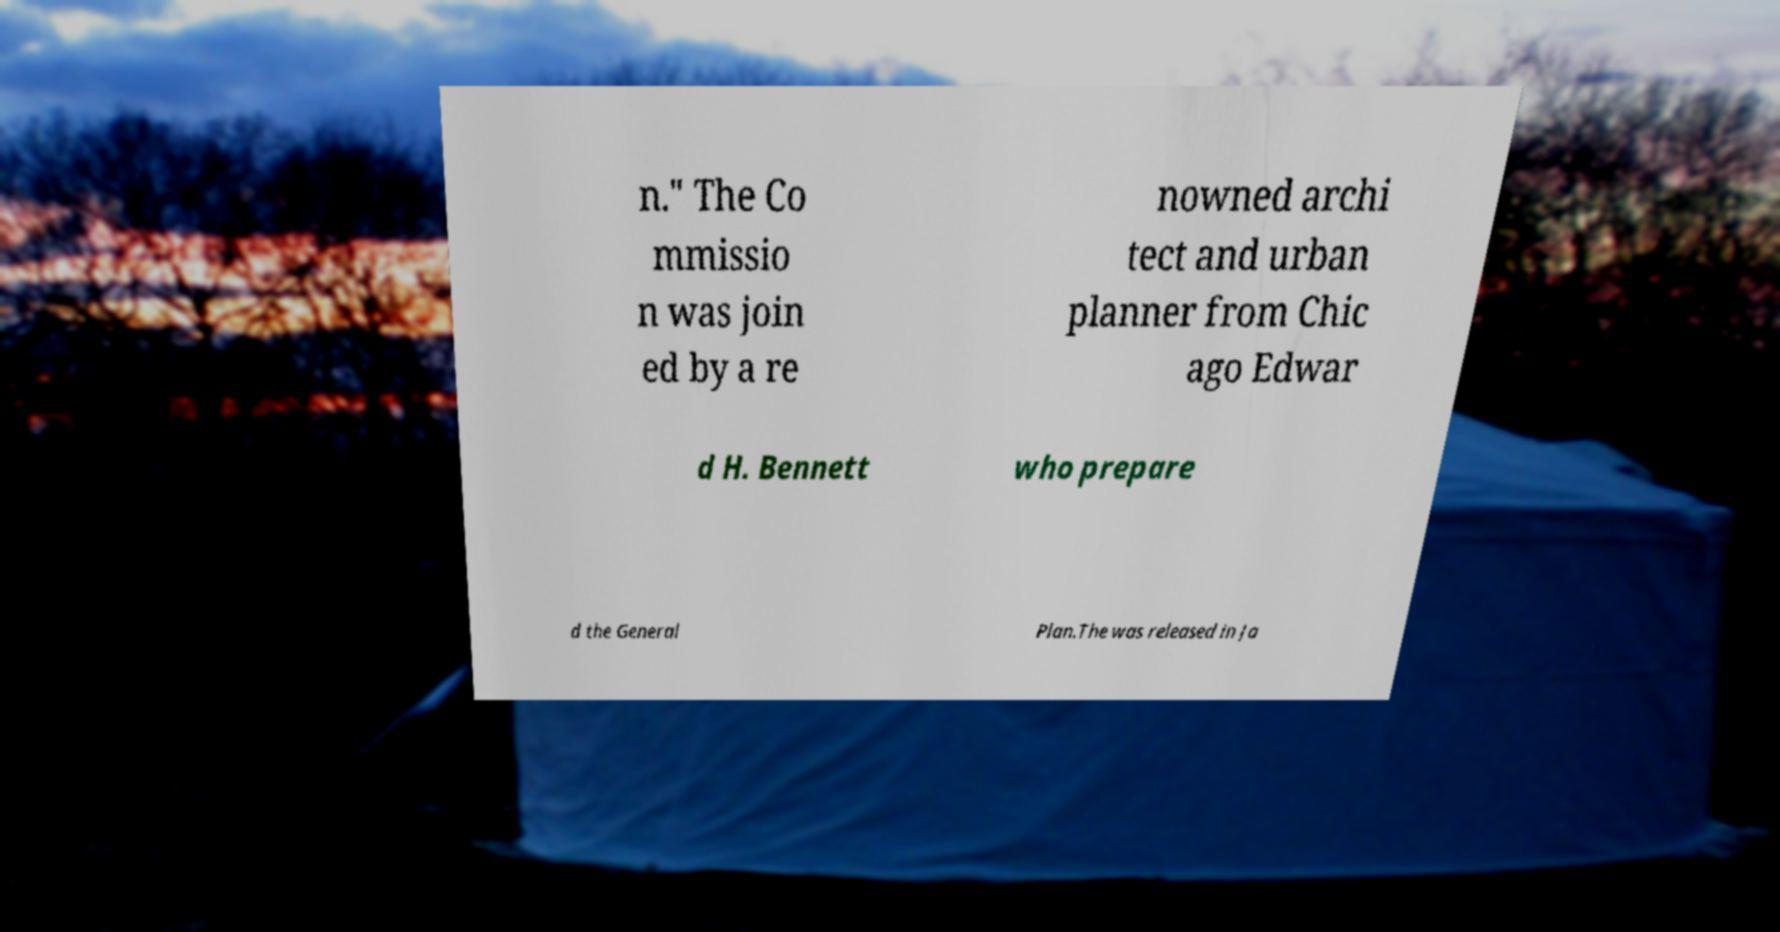Can you read and provide the text displayed in the image?This photo seems to have some interesting text. Can you extract and type it out for me? n." The Co mmissio n was join ed by a re nowned archi tect and urban planner from Chic ago Edwar d H. Bennett who prepare d the General Plan.The was released in Ja 